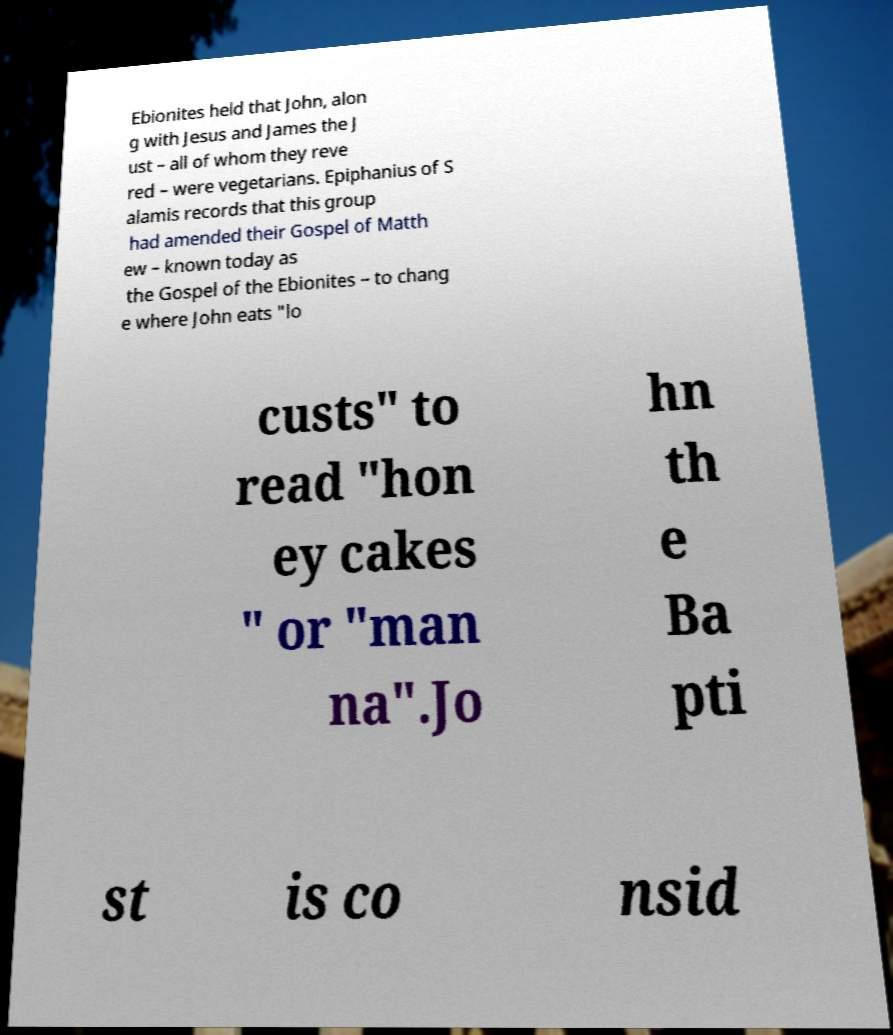Could you extract and type out the text from this image? Ebionites held that John, alon g with Jesus and James the J ust – all of whom they reve red – were vegetarians. Epiphanius of S alamis records that this group had amended their Gospel of Matth ew – known today as the Gospel of the Ebionites – to chang e where John eats "lo custs" to read "hon ey cakes " or "man na".Jo hn th e Ba pti st is co nsid 